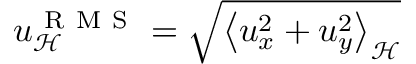Convert formula to latex. <formula><loc_0><loc_0><loc_500><loc_500>u _ { \mathcal { H } } ^ { R M S } = \sqrt { \left < u _ { x } ^ { 2 } + u _ { y } ^ { 2 } \right > _ { \mathcal { H } } }</formula> 